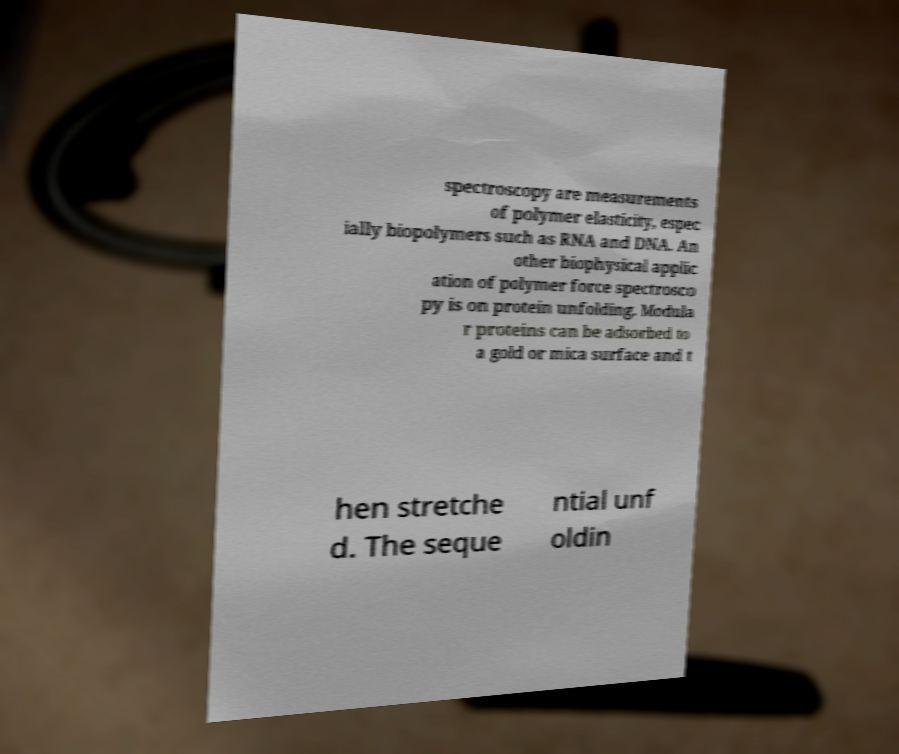Please identify and transcribe the text found in this image. spectroscopy are measurements of polymer elasticity, espec ially biopolymers such as RNA and DNA. An other biophysical applic ation of polymer force spectrosco py is on protein unfolding. Modula r proteins can be adsorbed to a gold or mica surface and t hen stretche d. The seque ntial unf oldin 